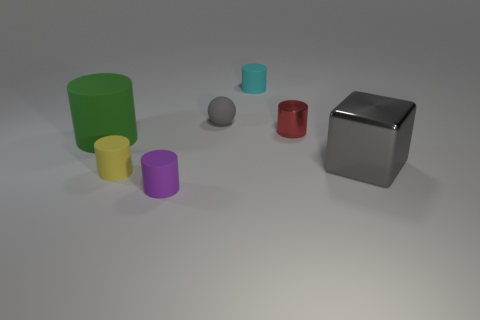Subtract all tiny red cylinders. How many cylinders are left? 4 Subtract all cyan cylinders. How many cylinders are left? 4 Subtract all gray cylinders. Subtract all brown spheres. How many cylinders are left? 5 Add 3 small yellow matte things. How many objects exist? 10 Subtract all balls. How many objects are left? 6 Add 7 small yellow objects. How many small yellow objects are left? 8 Add 4 cyan cylinders. How many cyan cylinders exist? 5 Subtract 0 brown cylinders. How many objects are left? 7 Subtract all red shiny cylinders. Subtract all small objects. How many objects are left? 1 